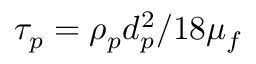Convert formula to latex. <formula><loc_0><loc_0><loc_500><loc_500>\tau _ { p } = \rho _ { p } d _ { p } ^ { 2 } / 1 8 \mu _ { f }</formula> 